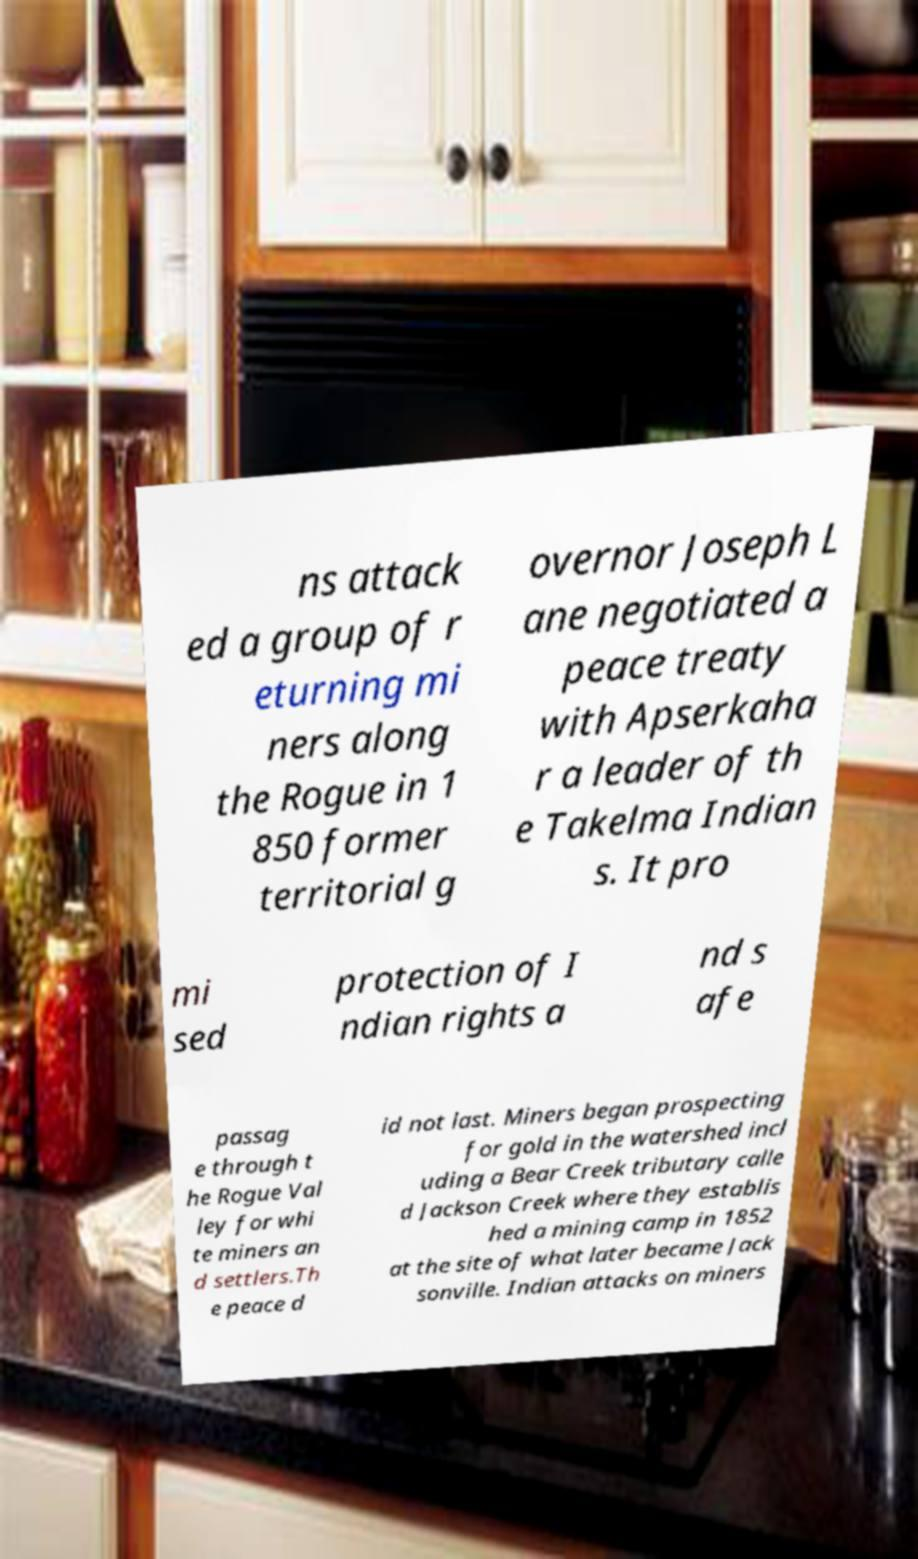Can you accurately transcribe the text from the provided image for me? ns attack ed a group of r eturning mi ners along the Rogue in 1 850 former territorial g overnor Joseph L ane negotiated a peace treaty with Apserkaha r a leader of th e Takelma Indian s. It pro mi sed protection of I ndian rights a nd s afe passag e through t he Rogue Val ley for whi te miners an d settlers.Th e peace d id not last. Miners began prospecting for gold in the watershed incl uding a Bear Creek tributary calle d Jackson Creek where they establis hed a mining camp in 1852 at the site of what later became Jack sonville. Indian attacks on miners 